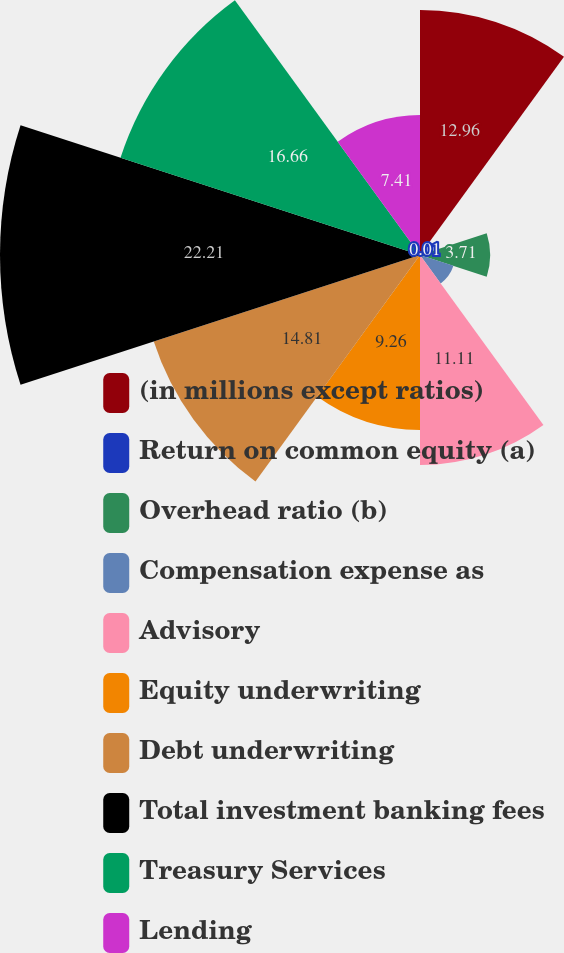Convert chart. <chart><loc_0><loc_0><loc_500><loc_500><pie_chart><fcel>(in millions except ratios)<fcel>Return on common equity (a)<fcel>Overhead ratio (b)<fcel>Compensation expense as<fcel>Advisory<fcel>Equity underwriting<fcel>Debt underwriting<fcel>Total investment banking fees<fcel>Treasury Services<fcel>Lending<nl><fcel>12.96%<fcel>0.01%<fcel>3.71%<fcel>1.86%<fcel>11.11%<fcel>9.26%<fcel>14.81%<fcel>22.22%<fcel>16.66%<fcel>7.41%<nl></chart> 